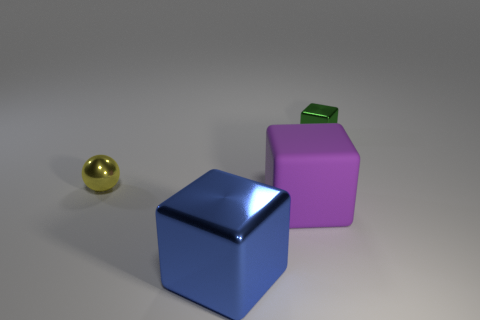Add 1 yellow balls. How many objects exist? 5 Subtract all balls. How many objects are left? 3 Add 2 purple cubes. How many purple cubes are left? 3 Add 4 rubber blocks. How many rubber blocks exist? 5 Subtract 0 blue spheres. How many objects are left? 4 Subtract all big blue cubes. Subtract all small green objects. How many objects are left? 2 